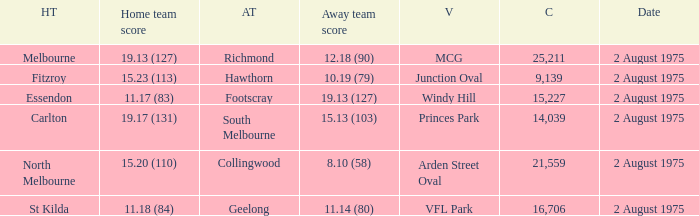What did the away team score when playing North Melbourne? 8.10 (58). 